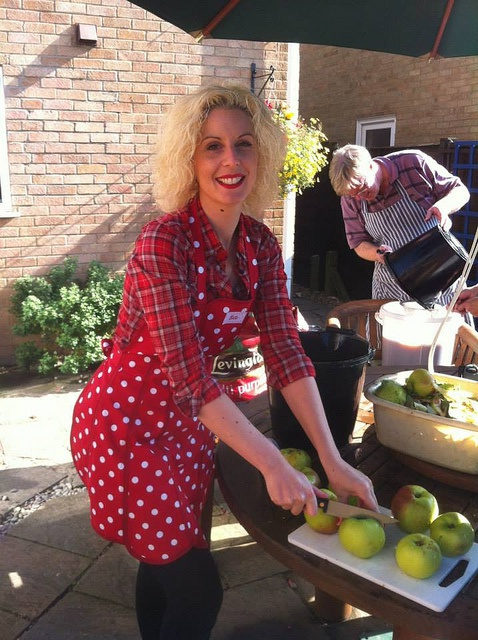Describe the objects in this image and their specific colors. I can see people in tan, maroon, brown, and black tones, people in tan, white, gray, purple, and brown tones, apple in tan, olive, and gray tones, apple in tan, olive, maroon, and black tones, and apple in tan, olive, and darkgreen tones in this image. 